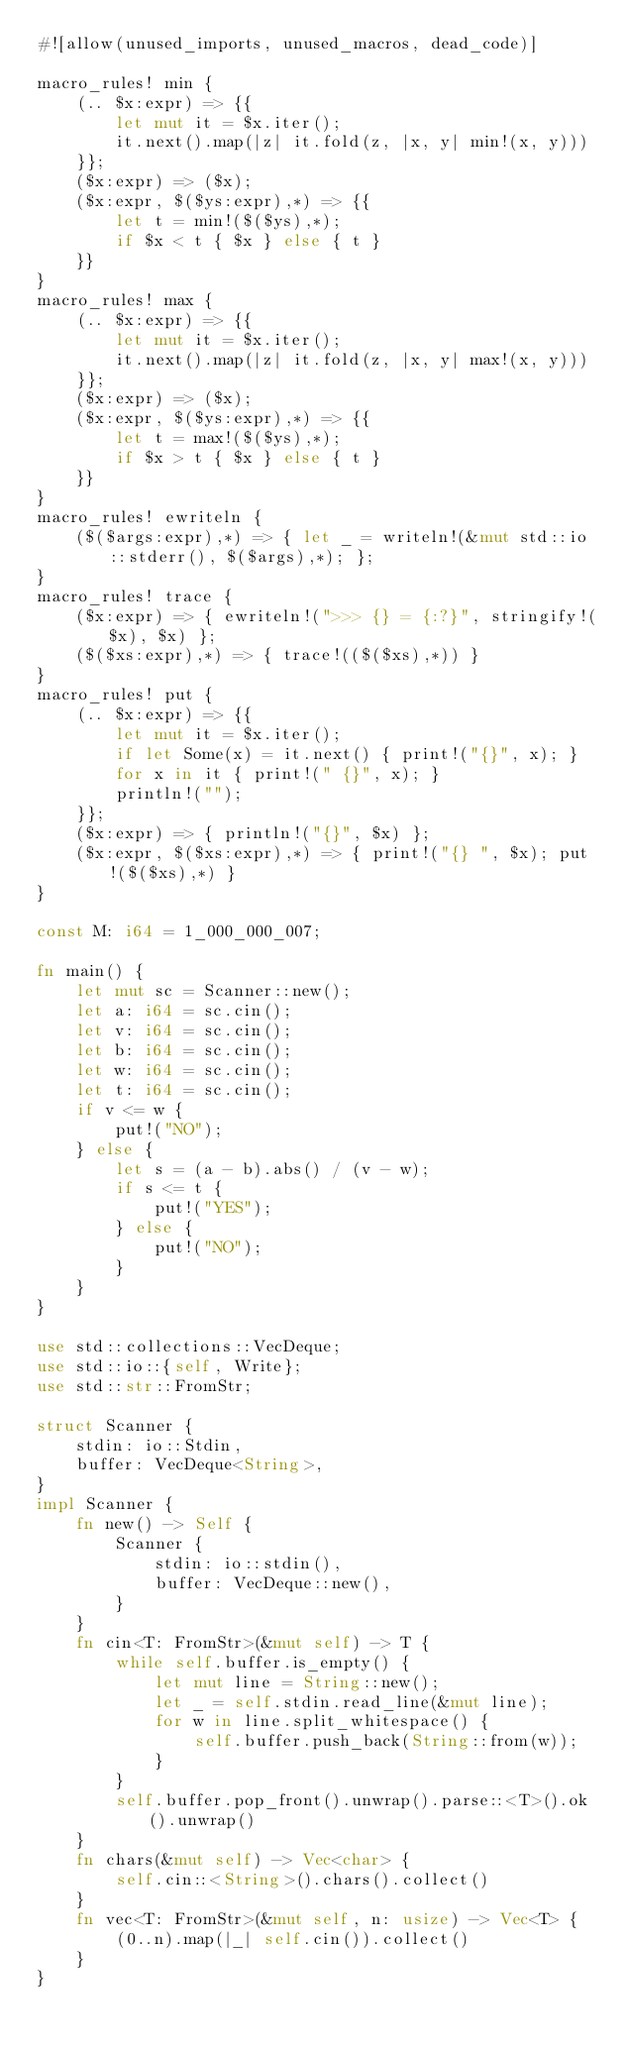<code> <loc_0><loc_0><loc_500><loc_500><_Rust_>#![allow(unused_imports, unused_macros, dead_code)]

macro_rules! min {
    (.. $x:expr) => {{
        let mut it = $x.iter();
        it.next().map(|z| it.fold(z, |x, y| min!(x, y)))
    }};
    ($x:expr) => ($x);
    ($x:expr, $($ys:expr),*) => {{
        let t = min!($($ys),*);
        if $x < t { $x } else { t }
    }}
}
macro_rules! max {
    (.. $x:expr) => {{
        let mut it = $x.iter();
        it.next().map(|z| it.fold(z, |x, y| max!(x, y)))
    }};
    ($x:expr) => ($x);
    ($x:expr, $($ys:expr),*) => {{
        let t = max!($($ys),*);
        if $x > t { $x } else { t }
    }}
}
macro_rules! ewriteln {
    ($($args:expr),*) => { let _ = writeln!(&mut std::io::stderr(), $($args),*); };
}
macro_rules! trace {
    ($x:expr) => { ewriteln!(">>> {} = {:?}", stringify!($x), $x) };
    ($($xs:expr),*) => { trace!(($($xs),*)) }
}
macro_rules! put {
    (.. $x:expr) => {{
        let mut it = $x.iter();
        if let Some(x) = it.next() { print!("{}", x); }
        for x in it { print!(" {}", x); }
        println!("");
    }};
    ($x:expr) => { println!("{}", $x) };
    ($x:expr, $($xs:expr),*) => { print!("{} ", $x); put!($($xs),*) }
}

const M: i64 = 1_000_000_007;

fn main() {
    let mut sc = Scanner::new();
    let a: i64 = sc.cin();
    let v: i64 = sc.cin();
    let b: i64 = sc.cin();
    let w: i64 = sc.cin();
    let t: i64 = sc.cin();
    if v <= w {
        put!("NO");
    } else {
        let s = (a - b).abs() / (v - w);
        if s <= t {
            put!("YES");
        } else {
            put!("NO");
        }
    }
}

use std::collections::VecDeque;
use std::io::{self, Write};
use std::str::FromStr;

struct Scanner {
    stdin: io::Stdin,
    buffer: VecDeque<String>,
}
impl Scanner {
    fn new() -> Self {
        Scanner {
            stdin: io::stdin(),
            buffer: VecDeque::new(),
        }
    }
    fn cin<T: FromStr>(&mut self) -> T {
        while self.buffer.is_empty() {
            let mut line = String::new();
            let _ = self.stdin.read_line(&mut line);
            for w in line.split_whitespace() {
                self.buffer.push_back(String::from(w));
            }
        }
        self.buffer.pop_front().unwrap().parse::<T>().ok().unwrap()
    }
    fn chars(&mut self) -> Vec<char> {
        self.cin::<String>().chars().collect()
    }
    fn vec<T: FromStr>(&mut self, n: usize) -> Vec<T> {
        (0..n).map(|_| self.cin()).collect()
    }
}
</code> 